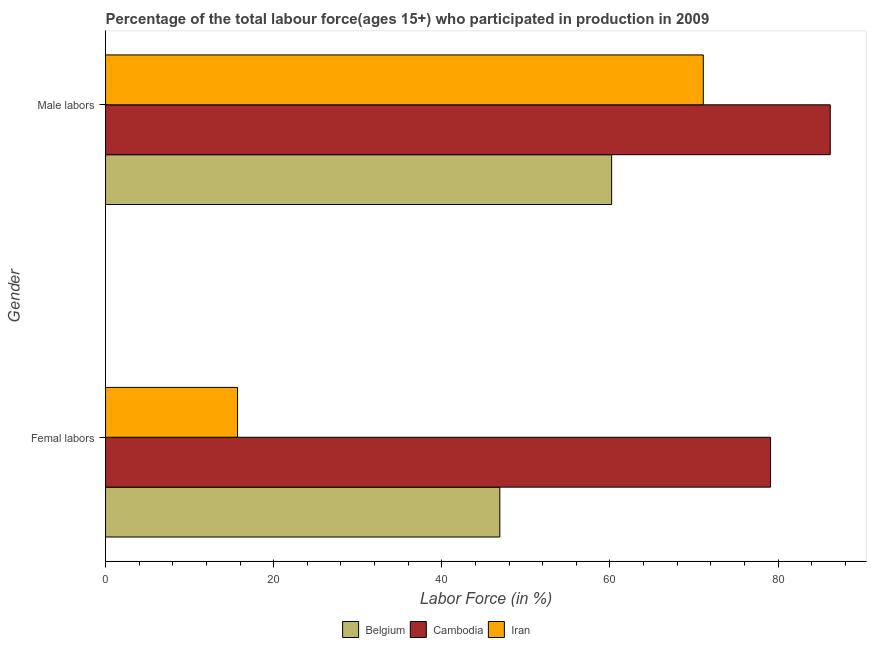How many different coloured bars are there?
Offer a terse response. 3. Are the number of bars per tick equal to the number of legend labels?
Make the answer very short. Yes. How many bars are there on the 2nd tick from the top?
Offer a terse response. 3. What is the label of the 1st group of bars from the top?
Your answer should be compact. Male labors. What is the percentage of female labor force in Belgium?
Provide a succinct answer. 46.9. Across all countries, what is the maximum percentage of female labor force?
Ensure brevity in your answer.  79.1. Across all countries, what is the minimum percentage of female labor force?
Your answer should be very brief. 15.7. In which country was the percentage of male labour force maximum?
Keep it short and to the point. Cambodia. What is the total percentage of male labour force in the graph?
Your response must be concise. 217.5. What is the difference between the percentage of male labour force in Iran and that in Cambodia?
Provide a succinct answer. -15.1. What is the difference between the percentage of female labor force in Belgium and the percentage of male labour force in Iran?
Keep it short and to the point. -24.2. What is the average percentage of female labor force per country?
Ensure brevity in your answer.  47.23. What is the difference between the percentage of female labor force and percentage of male labour force in Iran?
Make the answer very short. -55.4. In how many countries, is the percentage of male labour force greater than 80 %?
Give a very brief answer. 1. What is the ratio of the percentage of male labour force in Cambodia to that in Belgium?
Offer a terse response. 1.43. Is the percentage of female labor force in Belgium less than that in Iran?
Your answer should be compact. No. How many bars are there?
Your answer should be compact. 6. Are all the bars in the graph horizontal?
Offer a very short reply. Yes. Does the graph contain grids?
Keep it short and to the point. No. Where does the legend appear in the graph?
Give a very brief answer. Bottom center. How many legend labels are there?
Your response must be concise. 3. How are the legend labels stacked?
Your answer should be very brief. Horizontal. What is the title of the graph?
Offer a terse response. Percentage of the total labour force(ages 15+) who participated in production in 2009. Does "Bahamas" appear as one of the legend labels in the graph?
Offer a very short reply. No. What is the label or title of the Y-axis?
Your answer should be very brief. Gender. What is the Labor Force (in %) in Belgium in Femal labors?
Give a very brief answer. 46.9. What is the Labor Force (in %) of Cambodia in Femal labors?
Make the answer very short. 79.1. What is the Labor Force (in %) of Iran in Femal labors?
Offer a terse response. 15.7. What is the Labor Force (in %) of Belgium in Male labors?
Offer a very short reply. 60.2. What is the Labor Force (in %) of Cambodia in Male labors?
Give a very brief answer. 86.2. What is the Labor Force (in %) of Iran in Male labors?
Provide a succinct answer. 71.1. Across all Gender, what is the maximum Labor Force (in %) in Belgium?
Keep it short and to the point. 60.2. Across all Gender, what is the maximum Labor Force (in %) in Cambodia?
Provide a short and direct response. 86.2. Across all Gender, what is the maximum Labor Force (in %) of Iran?
Your response must be concise. 71.1. Across all Gender, what is the minimum Labor Force (in %) of Belgium?
Your response must be concise. 46.9. Across all Gender, what is the minimum Labor Force (in %) in Cambodia?
Offer a terse response. 79.1. Across all Gender, what is the minimum Labor Force (in %) of Iran?
Provide a succinct answer. 15.7. What is the total Labor Force (in %) in Belgium in the graph?
Your answer should be very brief. 107.1. What is the total Labor Force (in %) of Cambodia in the graph?
Give a very brief answer. 165.3. What is the total Labor Force (in %) of Iran in the graph?
Offer a very short reply. 86.8. What is the difference between the Labor Force (in %) in Iran in Femal labors and that in Male labors?
Your response must be concise. -55.4. What is the difference between the Labor Force (in %) in Belgium in Femal labors and the Labor Force (in %) in Cambodia in Male labors?
Offer a terse response. -39.3. What is the difference between the Labor Force (in %) of Belgium in Femal labors and the Labor Force (in %) of Iran in Male labors?
Provide a succinct answer. -24.2. What is the difference between the Labor Force (in %) of Cambodia in Femal labors and the Labor Force (in %) of Iran in Male labors?
Ensure brevity in your answer.  8. What is the average Labor Force (in %) in Belgium per Gender?
Ensure brevity in your answer.  53.55. What is the average Labor Force (in %) in Cambodia per Gender?
Provide a succinct answer. 82.65. What is the average Labor Force (in %) in Iran per Gender?
Give a very brief answer. 43.4. What is the difference between the Labor Force (in %) in Belgium and Labor Force (in %) in Cambodia in Femal labors?
Your answer should be very brief. -32.2. What is the difference between the Labor Force (in %) in Belgium and Labor Force (in %) in Iran in Femal labors?
Your answer should be very brief. 31.2. What is the difference between the Labor Force (in %) of Cambodia and Labor Force (in %) of Iran in Femal labors?
Your answer should be compact. 63.4. What is the difference between the Labor Force (in %) in Belgium and Labor Force (in %) in Cambodia in Male labors?
Provide a succinct answer. -26. What is the difference between the Labor Force (in %) of Cambodia and Labor Force (in %) of Iran in Male labors?
Your response must be concise. 15.1. What is the ratio of the Labor Force (in %) of Belgium in Femal labors to that in Male labors?
Offer a terse response. 0.78. What is the ratio of the Labor Force (in %) of Cambodia in Femal labors to that in Male labors?
Keep it short and to the point. 0.92. What is the ratio of the Labor Force (in %) in Iran in Femal labors to that in Male labors?
Ensure brevity in your answer.  0.22. What is the difference between the highest and the second highest Labor Force (in %) of Cambodia?
Give a very brief answer. 7.1. What is the difference between the highest and the second highest Labor Force (in %) in Iran?
Give a very brief answer. 55.4. What is the difference between the highest and the lowest Labor Force (in %) in Iran?
Give a very brief answer. 55.4. 